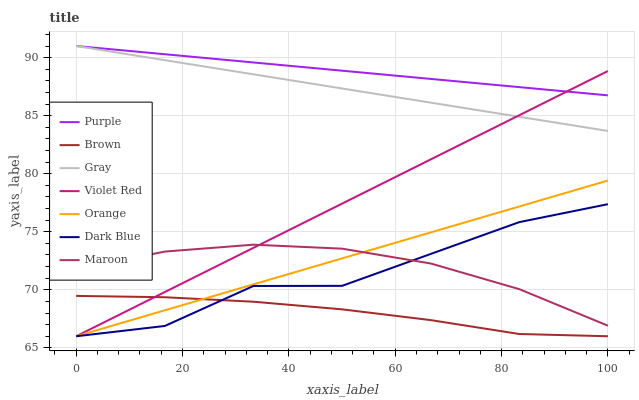Does Brown have the minimum area under the curve?
Answer yes or no. Yes. Does Purple have the maximum area under the curve?
Answer yes or no. Yes. Does Violet Red have the minimum area under the curve?
Answer yes or no. No. Does Violet Red have the maximum area under the curve?
Answer yes or no. No. Is Gray the smoothest?
Answer yes or no. Yes. Is Dark Blue the roughest?
Answer yes or no. Yes. Is Violet Red the smoothest?
Answer yes or no. No. Is Violet Red the roughest?
Answer yes or no. No. Does Brown have the lowest value?
Answer yes or no. Yes. Does Gray have the lowest value?
Answer yes or no. No. Does Purple have the highest value?
Answer yes or no. Yes. Does Violet Red have the highest value?
Answer yes or no. No. Is Brown less than Maroon?
Answer yes or no. Yes. Is Purple greater than Brown?
Answer yes or no. Yes. Does Gray intersect Purple?
Answer yes or no. Yes. Is Gray less than Purple?
Answer yes or no. No. Is Gray greater than Purple?
Answer yes or no. No. Does Brown intersect Maroon?
Answer yes or no. No. 